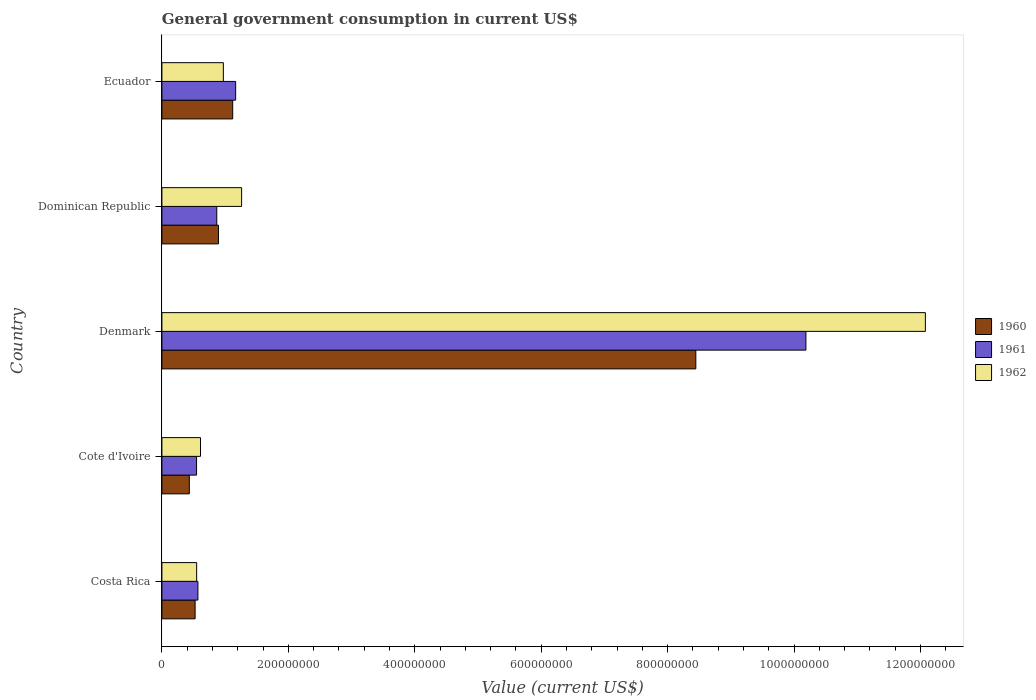How many different coloured bars are there?
Make the answer very short. 3. How many groups of bars are there?
Your answer should be compact. 5. Are the number of bars per tick equal to the number of legend labels?
Your answer should be compact. Yes. Are the number of bars on each tick of the Y-axis equal?
Give a very brief answer. Yes. How many bars are there on the 2nd tick from the top?
Make the answer very short. 3. How many bars are there on the 2nd tick from the bottom?
Give a very brief answer. 3. In how many cases, is the number of bars for a given country not equal to the number of legend labels?
Provide a short and direct response. 0. What is the government conusmption in 1960 in Cote d'Ivoire?
Keep it short and to the point. 4.34e+07. Across all countries, what is the maximum government conusmption in 1961?
Your answer should be compact. 1.02e+09. Across all countries, what is the minimum government conusmption in 1960?
Your answer should be very brief. 4.34e+07. In which country was the government conusmption in 1960 maximum?
Make the answer very short. Denmark. In which country was the government conusmption in 1960 minimum?
Your answer should be very brief. Cote d'Ivoire. What is the total government conusmption in 1962 in the graph?
Give a very brief answer. 1.55e+09. What is the difference between the government conusmption in 1960 in Denmark and that in Dominican Republic?
Your answer should be very brief. 7.55e+08. What is the difference between the government conusmption in 1961 in Denmark and the government conusmption in 1962 in Dominican Republic?
Provide a succinct answer. 8.93e+08. What is the average government conusmption in 1960 per country?
Offer a terse response. 2.28e+08. What is the difference between the government conusmption in 1960 and government conusmption in 1962 in Ecuador?
Your answer should be compact. 1.48e+07. What is the ratio of the government conusmption in 1960 in Dominican Republic to that in Ecuador?
Offer a very short reply. 0.8. Is the difference between the government conusmption in 1960 in Costa Rica and Denmark greater than the difference between the government conusmption in 1962 in Costa Rica and Denmark?
Offer a terse response. Yes. What is the difference between the highest and the second highest government conusmption in 1961?
Your answer should be compact. 9.02e+08. What is the difference between the highest and the lowest government conusmption in 1961?
Offer a very short reply. 9.64e+08. In how many countries, is the government conusmption in 1962 greater than the average government conusmption in 1962 taken over all countries?
Keep it short and to the point. 1. Is the sum of the government conusmption in 1960 in Cote d'Ivoire and Dominican Republic greater than the maximum government conusmption in 1962 across all countries?
Offer a terse response. No. What does the 3rd bar from the bottom in Costa Rica represents?
Keep it short and to the point. 1962. Is it the case that in every country, the sum of the government conusmption in 1960 and government conusmption in 1961 is greater than the government conusmption in 1962?
Ensure brevity in your answer.  Yes. How many bars are there?
Ensure brevity in your answer.  15. Are all the bars in the graph horizontal?
Your answer should be very brief. Yes. What is the difference between two consecutive major ticks on the X-axis?
Your answer should be very brief. 2.00e+08. Are the values on the major ticks of X-axis written in scientific E-notation?
Provide a succinct answer. No. Does the graph contain any zero values?
Your response must be concise. No. Does the graph contain grids?
Provide a succinct answer. No. Where does the legend appear in the graph?
Offer a terse response. Center right. How are the legend labels stacked?
Provide a short and direct response. Vertical. What is the title of the graph?
Your answer should be very brief. General government consumption in current US$. What is the label or title of the X-axis?
Provide a short and direct response. Value (current US$). What is the label or title of the Y-axis?
Ensure brevity in your answer.  Country. What is the Value (current US$) of 1960 in Costa Rica?
Give a very brief answer. 5.25e+07. What is the Value (current US$) of 1961 in Costa Rica?
Give a very brief answer. 5.70e+07. What is the Value (current US$) of 1962 in Costa Rica?
Your answer should be compact. 5.50e+07. What is the Value (current US$) of 1960 in Cote d'Ivoire?
Provide a succinct answer. 4.34e+07. What is the Value (current US$) in 1961 in Cote d'Ivoire?
Your answer should be very brief. 5.48e+07. What is the Value (current US$) of 1962 in Cote d'Ivoire?
Keep it short and to the point. 6.11e+07. What is the Value (current US$) of 1960 in Denmark?
Your answer should be compact. 8.45e+08. What is the Value (current US$) of 1961 in Denmark?
Provide a succinct answer. 1.02e+09. What is the Value (current US$) in 1962 in Denmark?
Keep it short and to the point. 1.21e+09. What is the Value (current US$) in 1960 in Dominican Republic?
Your answer should be compact. 8.95e+07. What is the Value (current US$) of 1961 in Dominican Republic?
Provide a succinct answer. 8.68e+07. What is the Value (current US$) in 1962 in Dominican Republic?
Offer a terse response. 1.26e+08. What is the Value (current US$) in 1960 in Ecuador?
Your answer should be very brief. 1.12e+08. What is the Value (current US$) of 1961 in Ecuador?
Your answer should be compact. 1.17e+08. What is the Value (current US$) of 1962 in Ecuador?
Offer a terse response. 9.72e+07. Across all countries, what is the maximum Value (current US$) of 1960?
Your response must be concise. 8.45e+08. Across all countries, what is the maximum Value (current US$) in 1961?
Your response must be concise. 1.02e+09. Across all countries, what is the maximum Value (current US$) of 1962?
Your answer should be very brief. 1.21e+09. Across all countries, what is the minimum Value (current US$) of 1960?
Give a very brief answer. 4.34e+07. Across all countries, what is the minimum Value (current US$) of 1961?
Your response must be concise. 5.48e+07. Across all countries, what is the minimum Value (current US$) of 1962?
Your response must be concise. 5.50e+07. What is the total Value (current US$) of 1960 in the graph?
Keep it short and to the point. 1.14e+09. What is the total Value (current US$) in 1961 in the graph?
Your answer should be compact. 1.33e+09. What is the total Value (current US$) of 1962 in the graph?
Ensure brevity in your answer.  1.55e+09. What is the difference between the Value (current US$) in 1960 in Costa Rica and that in Cote d'Ivoire?
Offer a very short reply. 9.18e+06. What is the difference between the Value (current US$) in 1961 in Costa Rica and that in Cote d'Ivoire?
Make the answer very short. 2.13e+06. What is the difference between the Value (current US$) in 1962 in Costa Rica and that in Cote d'Ivoire?
Give a very brief answer. -6.12e+06. What is the difference between the Value (current US$) of 1960 in Costa Rica and that in Denmark?
Your response must be concise. -7.92e+08. What is the difference between the Value (current US$) of 1961 in Costa Rica and that in Denmark?
Your answer should be compact. -9.62e+08. What is the difference between the Value (current US$) of 1962 in Costa Rica and that in Denmark?
Ensure brevity in your answer.  -1.15e+09. What is the difference between the Value (current US$) of 1960 in Costa Rica and that in Dominican Republic?
Offer a very short reply. -3.70e+07. What is the difference between the Value (current US$) of 1961 in Costa Rica and that in Dominican Republic?
Keep it short and to the point. -2.98e+07. What is the difference between the Value (current US$) of 1962 in Costa Rica and that in Dominican Republic?
Your answer should be very brief. -7.11e+07. What is the difference between the Value (current US$) of 1960 in Costa Rica and that in Ecuador?
Provide a short and direct response. -5.95e+07. What is the difference between the Value (current US$) of 1961 in Costa Rica and that in Ecuador?
Ensure brevity in your answer.  -5.97e+07. What is the difference between the Value (current US$) in 1962 in Costa Rica and that in Ecuador?
Provide a short and direct response. -4.23e+07. What is the difference between the Value (current US$) of 1960 in Cote d'Ivoire and that in Denmark?
Keep it short and to the point. -8.01e+08. What is the difference between the Value (current US$) in 1961 in Cote d'Ivoire and that in Denmark?
Your response must be concise. -9.64e+08. What is the difference between the Value (current US$) in 1962 in Cote d'Ivoire and that in Denmark?
Offer a terse response. -1.15e+09. What is the difference between the Value (current US$) in 1960 in Cote d'Ivoire and that in Dominican Republic?
Provide a short and direct response. -4.61e+07. What is the difference between the Value (current US$) in 1961 in Cote d'Ivoire and that in Dominican Republic?
Your answer should be compact. -3.20e+07. What is the difference between the Value (current US$) of 1962 in Cote d'Ivoire and that in Dominican Republic?
Offer a very short reply. -6.50e+07. What is the difference between the Value (current US$) in 1960 in Cote d'Ivoire and that in Ecuador?
Provide a short and direct response. -6.87e+07. What is the difference between the Value (current US$) in 1961 in Cote d'Ivoire and that in Ecuador?
Your answer should be very brief. -6.18e+07. What is the difference between the Value (current US$) of 1962 in Cote d'Ivoire and that in Ecuador?
Offer a very short reply. -3.61e+07. What is the difference between the Value (current US$) in 1960 in Denmark and that in Dominican Republic?
Offer a terse response. 7.55e+08. What is the difference between the Value (current US$) of 1961 in Denmark and that in Dominican Republic?
Provide a short and direct response. 9.32e+08. What is the difference between the Value (current US$) of 1962 in Denmark and that in Dominican Republic?
Keep it short and to the point. 1.08e+09. What is the difference between the Value (current US$) of 1960 in Denmark and that in Ecuador?
Keep it short and to the point. 7.33e+08. What is the difference between the Value (current US$) of 1961 in Denmark and that in Ecuador?
Your answer should be compact. 9.02e+08. What is the difference between the Value (current US$) of 1962 in Denmark and that in Ecuador?
Your response must be concise. 1.11e+09. What is the difference between the Value (current US$) of 1960 in Dominican Republic and that in Ecuador?
Ensure brevity in your answer.  -2.25e+07. What is the difference between the Value (current US$) of 1961 in Dominican Republic and that in Ecuador?
Keep it short and to the point. -2.99e+07. What is the difference between the Value (current US$) in 1962 in Dominican Republic and that in Ecuador?
Keep it short and to the point. 2.89e+07. What is the difference between the Value (current US$) of 1960 in Costa Rica and the Value (current US$) of 1961 in Cote d'Ivoire?
Give a very brief answer. -2.31e+06. What is the difference between the Value (current US$) of 1960 in Costa Rica and the Value (current US$) of 1962 in Cote d'Ivoire?
Provide a succinct answer. -8.57e+06. What is the difference between the Value (current US$) in 1961 in Costa Rica and the Value (current US$) in 1962 in Cote d'Ivoire?
Offer a terse response. -4.12e+06. What is the difference between the Value (current US$) in 1960 in Costa Rica and the Value (current US$) in 1961 in Denmark?
Provide a short and direct response. -9.66e+08. What is the difference between the Value (current US$) of 1960 in Costa Rica and the Value (current US$) of 1962 in Denmark?
Give a very brief answer. -1.16e+09. What is the difference between the Value (current US$) of 1961 in Costa Rica and the Value (current US$) of 1962 in Denmark?
Your answer should be compact. -1.15e+09. What is the difference between the Value (current US$) in 1960 in Costa Rica and the Value (current US$) in 1961 in Dominican Republic?
Offer a terse response. -3.43e+07. What is the difference between the Value (current US$) in 1960 in Costa Rica and the Value (current US$) in 1962 in Dominican Republic?
Offer a terse response. -7.36e+07. What is the difference between the Value (current US$) in 1961 in Costa Rica and the Value (current US$) in 1962 in Dominican Republic?
Your response must be concise. -6.91e+07. What is the difference between the Value (current US$) of 1960 in Costa Rica and the Value (current US$) of 1961 in Ecuador?
Keep it short and to the point. -6.41e+07. What is the difference between the Value (current US$) of 1960 in Costa Rica and the Value (current US$) of 1962 in Ecuador?
Give a very brief answer. -4.47e+07. What is the difference between the Value (current US$) of 1961 in Costa Rica and the Value (current US$) of 1962 in Ecuador?
Provide a short and direct response. -4.03e+07. What is the difference between the Value (current US$) of 1960 in Cote d'Ivoire and the Value (current US$) of 1961 in Denmark?
Provide a short and direct response. -9.75e+08. What is the difference between the Value (current US$) of 1960 in Cote d'Ivoire and the Value (current US$) of 1962 in Denmark?
Keep it short and to the point. -1.16e+09. What is the difference between the Value (current US$) of 1961 in Cote d'Ivoire and the Value (current US$) of 1962 in Denmark?
Ensure brevity in your answer.  -1.15e+09. What is the difference between the Value (current US$) in 1960 in Cote d'Ivoire and the Value (current US$) in 1961 in Dominican Republic?
Offer a very short reply. -4.34e+07. What is the difference between the Value (current US$) in 1960 in Cote d'Ivoire and the Value (current US$) in 1962 in Dominican Republic?
Give a very brief answer. -8.27e+07. What is the difference between the Value (current US$) of 1961 in Cote d'Ivoire and the Value (current US$) of 1962 in Dominican Republic?
Offer a very short reply. -7.13e+07. What is the difference between the Value (current US$) of 1960 in Cote d'Ivoire and the Value (current US$) of 1961 in Ecuador?
Provide a succinct answer. -7.33e+07. What is the difference between the Value (current US$) in 1960 in Cote d'Ivoire and the Value (current US$) in 1962 in Ecuador?
Give a very brief answer. -5.39e+07. What is the difference between the Value (current US$) of 1961 in Cote d'Ivoire and the Value (current US$) of 1962 in Ecuador?
Offer a very short reply. -4.24e+07. What is the difference between the Value (current US$) in 1960 in Denmark and the Value (current US$) in 1961 in Dominican Republic?
Make the answer very short. 7.58e+08. What is the difference between the Value (current US$) in 1960 in Denmark and the Value (current US$) in 1962 in Dominican Republic?
Provide a succinct answer. 7.19e+08. What is the difference between the Value (current US$) in 1961 in Denmark and the Value (current US$) in 1962 in Dominican Republic?
Offer a very short reply. 8.93e+08. What is the difference between the Value (current US$) of 1960 in Denmark and the Value (current US$) of 1961 in Ecuador?
Your response must be concise. 7.28e+08. What is the difference between the Value (current US$) in 1960 in Denmark and the Value (current US$) in 1962 in Ecuador?
Your answer should be very brief. 7.47e+08. What is the difference between the Value (current US$) in 1961 in Denmark and the Value (current US$) in 1962 in Ecuador?
Keep it short and to the point. 9.22e+08. What is the difference between the Value (current US$) in 1960 in Dominican Republic and the Value (current US$) in 1961 in Ecuador?
Offer a very short reply. -2.72e+07. What is the difference between the Value (current US$) in 1960 in Dominican Republic and the Value (current US$) in 1962 in Ecuador?
Offer a very short reply. -7.73e+06. What is the difference between the Value (current US$) in 1961 in Dominican Republic and the Value (current US$) in 1962 in Ecuador?
Offer a very short reply. -1.04e+07. What is the average Value (current US$) of 1960 per country?
Give a very brief answer. 2.28e+08. What is the average Value (current US$) in 1961 per country?
Provide a short and direct response. 2.67e+08. What is the average Value (current US$) in 1962 per country?
Offer a very short reply. 3.09e+08. What is the difference between the Value (current US$) of 1960 and Value (current US$) of 1961 in Costa Rica?
Give a very brief answer. -4.44e+06. What is the difference between the Value (current US$) of 1960 and Value (current US$) of 1962 in Costa Rica?
Offer a terse response. -2.44e+06. What is the difference between the Value (current US$) of 1961 and Value (current US$) of 1962 in Costa Rica?
Ensure brevity in your answer.  2.00e+06. What is the difference between the Value (current US$) of 1960 and Value (current US$) of 1961 in Cote d'Ivoire?
Ensure brevity in your answer.  -1.15e+07. What is the difference between the Value (current US$) of 1960 and Value (current US$) of 1962 in Cote d'Ivoire?
Provide a succinct answer. -1.77e+07. What is the difference between the Value (current US$) of 1961 and Value (current US$) of 1962 in Cote d'Ivoire?
Your response must be concise. -6.25e+06. What is the difference between the Value (current US$) in 1960 and Value (current US$) in 1961 in Denmark?
Provide a succinct answer. -1.74e+08. What is the difference between the Value (current US$) of 1960 and Value (current US$) of 1962 in Denmark?
Give a very brief answer. -3.63e+08. What is the difference between the Value (current US$) of 1961 and Value (current US$) of 1962 in Denmark?
Ensure brevity in your answer.  -1.89e+08. What is the difference between the Value (current US$) of 1960 and Value (current US$) of 1961 in Dominican Republic?
Give a very brief answer. 2.70e+06. What is the difference between the Value (current US$) in 1960 and Value (current US$) in 1962 in Dominican Republic?
Your answer should be very brief. -3.66e+07. What is the difference between the Value (current US$) in 1961 and Value (current US$) in 1962 in Dominican Republic?
Your answer should be very brief. -3.93e+07. What is the difference between the Value (current US$) of 1960 and Value (current US$) of 1961 in Ecuador?
Your answer should be compact. -4.67e+06. What is the difference between the Value (current US$) in 1960 and Value (current US$) in 1962 in Ecuador?
Offer a terse response. 1.48e+07. What is the difference between the Value (current US$) in 1961 and Value (current US$) in 1962 in Ecuador?
Offer a terse response. 1.94e+07. What is the ratio of the Value (current US$) of 1960 in Costa Rica to that in Cote d'Ivoire?
Give a very brief answer. 1.21. What is the ratio of the Value (current US$) of 1961 in Costa Rica to that in Cote d'Ivoire?
Your answer should be compact. 1.04. What is the ratio of the Value (current US$) in 1962 in Costa Rica to that in Cote d'Ivoire?
Provide a succinct answer. 0.9. What is the ratio of the Value (current US$) of 1960 in Costa Rica to that in Denmark?
Your response must be concise. 0.06. What is the ratio of the Value (current US$) of 1961 in Costa Rica to that in Denmark?
Offer a very short reply. 0.06. What is the ratio of the Value (current US$) of 1962 in Costa Rica to that in Denmark?
Ensure brevity in your answer.  0.05. What is the ratio of the Value (current US$) in 1960 in Costa Rica to that in Dominican Republic?
Provide a short and direct response. 0.59. What is the ratio of the Value (current US$) of 1961 in Costa Rica to that in Dominican Republic?
Your response must be concise. 0.66. What is the ratio of the Value (current US$) in 1962 in Costa Rica to that in Dominican Republic?
Your response must be concise. 0.44. What is the ratio of the Value (current US$) in 1960 in Costa Rica to that in Ecuador?
Your answer should be very brief. 0.47. What is the ratio of the Value (current US$) of 1961 in Costa Rica to that in Ecuador?
Give a very brief answer. 0.49. What is the ratio of the Value (current US$) in 1962 in Costa Rica to that in Ecuador?
Give a very brief answer. 0.57. What is the ratio of the Value (current US$) in 1960 in Cote d'Ivoire to that in Denmark?
Keep it short and to the point. 0.05. What is the ratio of the Value (current US$) of 1961 in Cote d'Ivoire to that in Denmark?
Make the answer very short. 0.05. What is the ratio of the Value (current US$) of 1962 in Cote d'Ivoire to that in Denmark?
Keep it short and to the point. 0.05. What is the ratio of the Value (current US$) of 1960 in Cote d'Ivoire to that in Dominican Republic?
Make the answer very short. 0.48. What is the ratio of the Value (current US$) of 1961 in Cote d'Ivoire to that in Dominican Republic?
Your answer should be very brief. 0.63. What is the ratio of the Value (current US$) in 1962 in Cote d'Ivoire to that in Dominican Republic?
Provide a short and direct response. 0.48. What is the ratio of the Value (current US$) in 1960 in Cote d'Ivoire to that in Ecuador?
Your answer should be compact. 0.39. What is the ratio of the Value (current US$) in 1961 in Cote d'Ivoire to that in Ecuador?
Keep it short and to the point. 0.47. What is the ratio of the Value (current US$) in 1962 in Cote d'Ivoire to that in Ecuador?
Offer a terse response. 0.63. What is the ratio of the Value (current US$) of 1960 in Denmark to that in Dominican Republic?
Give a very brief answer. 9.44. What is the ratio of the Value (current US$) of 1961 in Denmark to that in Dominican Republic?
Your answer should be very brief. 11.74. What is the ratio of the Value (current US$) of 1962 in Denmark to that in Dominican Republic?
Provide a succinct answer. 9.58. What is the ratio of the Value (current US$) of 1960 in Denmark to that in Ecuador?
Offer a terse response. 7.54. What is the ratio of the Value (current US$) in 1961 in Denmark to that in Ecuador?
Ensure brevity in your answer.  8.73. What is the ratio of the Value (current US$) in 1962 in Denmark to that in Ecuador?
Keep it short and to the point. 12.42. What is the ratio of the Value (current US$) of 1960 in Dominican Republic to that in Ecuador?
Provide a short and direct response. 0.8. What is the ratio of the Value (current US$) of 1961 in Dominican Republic to that in Ecuador?
Offer a very short reply. 0.74. What is the ratio of the Value (current US$) in 1962 in Dominican Republic to that in Ecuador?
Your response must be concise. 1.3. What is the difference between the highest and the second highest Value (current US$) of 1960?
Your answer should be very brief. 7.33e+08. What is the difference between the highest and the second highest Value (current US$) of 1961?
Your response must be concise. 9.02e+08. What is the difference between the highest and the second highest Value (current US$) in 1962?
Your answer should be compact. 1.08e+09. What is the difference between the highest and the lowest Value (current US$) of 1960?
Keep it short and to the point. 8.01e+08. What is the difference between the highest and the lowest Value (current US$) in 1961?
Your answer should be compact. 9.64e+08. What is the difference between the highest and the lowest Value (current US$) in 1962?
Ensure brevity in your answer.  1.15e+09. 